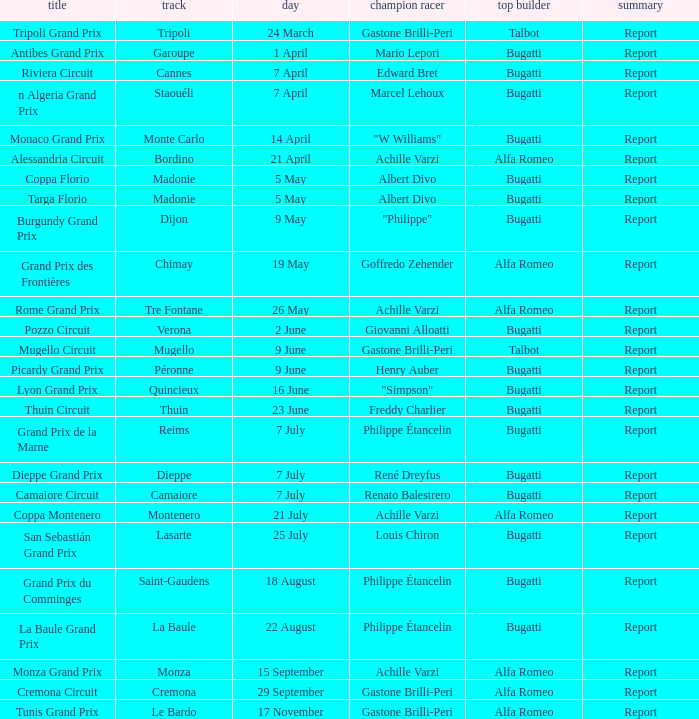What Winning driver has a Name of mugello circuit? Gastone Brilli-Peri. 